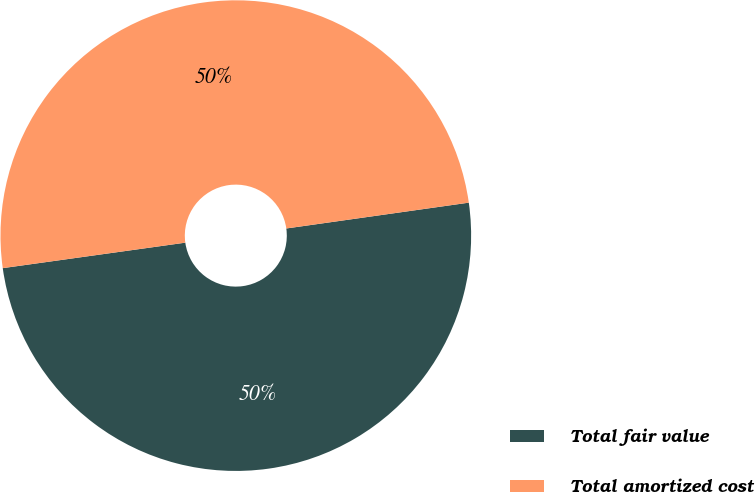<chart> <loc_0><loc_0><loc_500><loc_500><pie_chart><fcel>Total fair value<fcel>Total amortized cost<nl><fcel>50.03%<fcel>49.97%<nl></chart> 